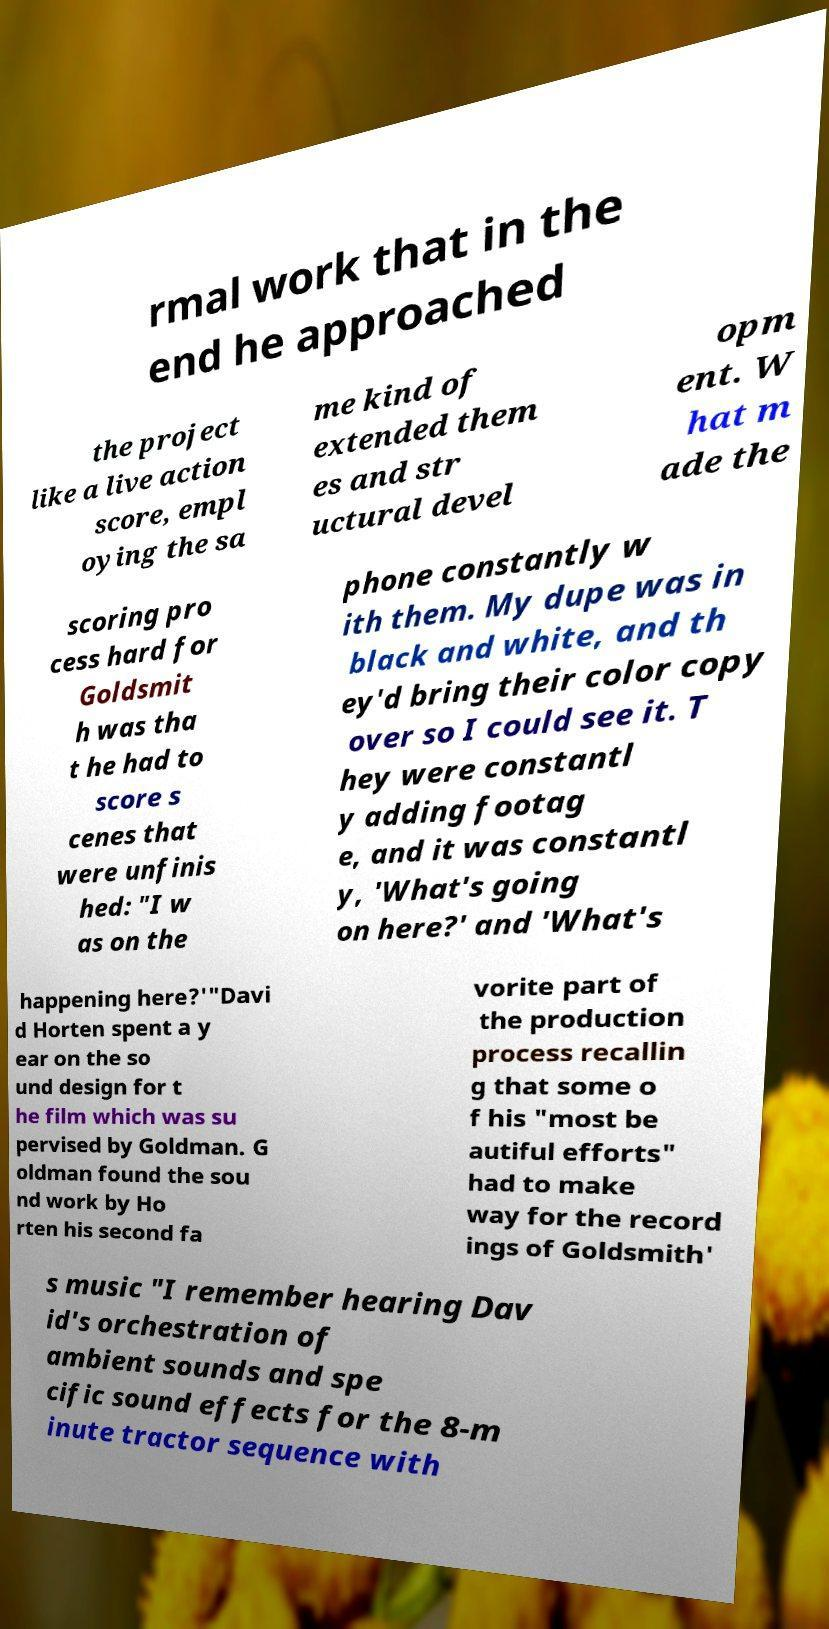Can you read and provide the text displayed in the image?This photo seems to have some interesting text. Can you extract and type it out for me? rmal work that in the end he approached the project like a live action score, empl oying the sa me kind of extended them es and str uctural devel opm ent. W hat m ade the scoring pro cess hard for Goldsmit h was tha t he had to score s cenes that were unfinis hed: "I w as on the phone constantly w ith them. My dupe was in black and white, and th ey'd bring their color copy over so I could see it. T hey were constantl y adding footag e, and it was constantl y, 'What's going on here?' and 'What's happening here?'"Davi d Horten spent a y ear on the so und design for t he film which was su pervised by Goldman. G oldman found the sou nd work by Ho rten his second fa vorite part of the production process recallin g that some o f his "most be autiful efforts" had to make way for the record ings of Goldsmith' s music "I remember hearing Dav id's orchestration of ambient sounds and spe cific sound effects for the 8-m inute tractor sequence with 